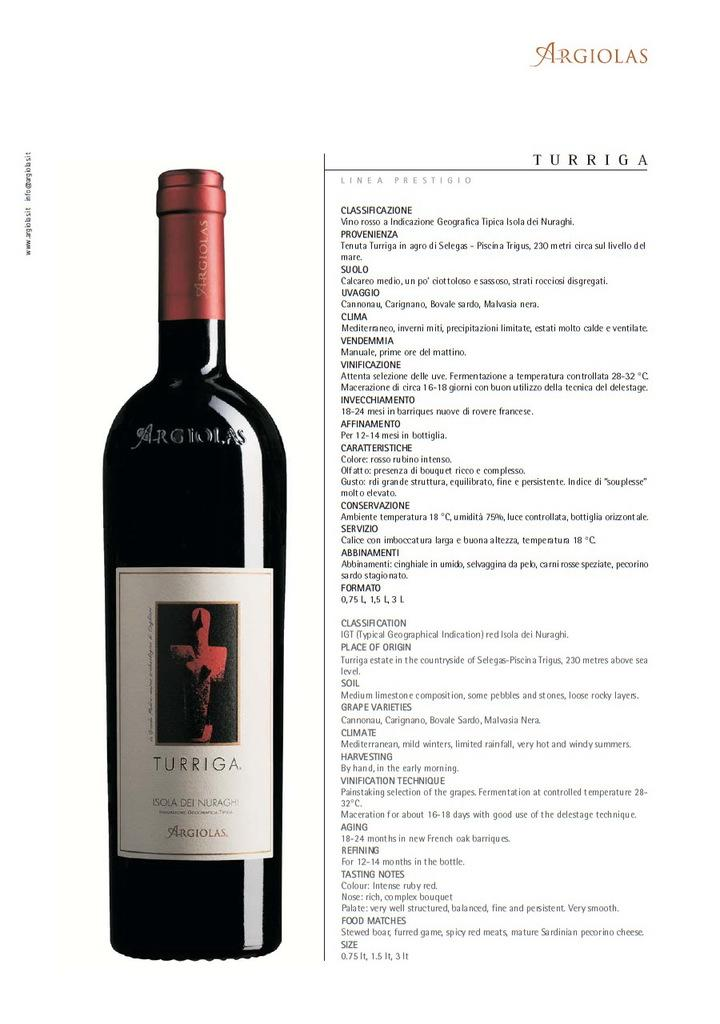What is present in the image that contains a picture? There is a paper in the image that contains a picture. What type of picture is on the paper? The picture on the paper is of a beverage bottle. Is there any text on the paper? Yes, there is text on the paper. Can you see a kitten playing with the paper in the image? There is no kitten present in the image, so it cannot be seen playing with the paper. 